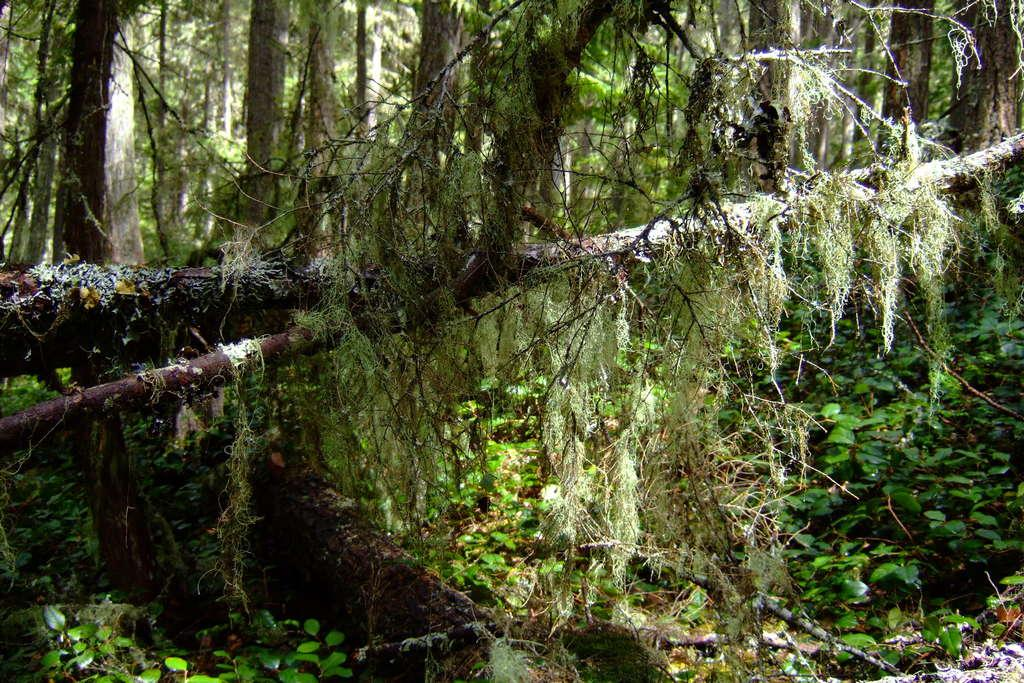What type of vegetation can be seen in the image? There are plants and trees in the image. Can you describe the branches in the foreground? In the foreground, there are branches of a tree. What type of neck accessory is being worn by the tree in the image? There are no neck accessories present in the image, as it features plants and trees. 